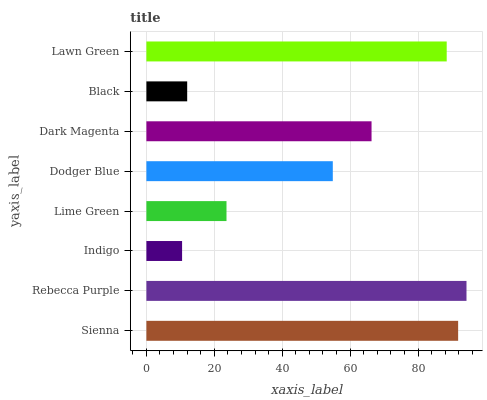Is Indigo the minimum?
Answer yes or no. Yes. Is Rebecca Purple the maximum?
Answer yes or no. Yes. Is Rebecca Purple the minimum?
Answer yes or no. No. Is Indigo the maximum?
Answer yes or no. No. Is Rebecca Purple greater than Indigo?
Answer yes or no. Yes. Is Indigo less than Rebecca Purple?
Answer yes or no. Yes. Is Indigo greater than Rebecca Purple?
Answer yes or no. No. Is Rebecca Purple less than Indigo?
Answer yes or no. No. Is Dark Magenta the high median?
Answer yes or no. Yes. Is Dodger Blue the low median?
Answer yes or no. Yes. Is Lawn Green the high median?
Answer yes or no. No. Is Lawn Green the low median?
Answer yes or no. No. 